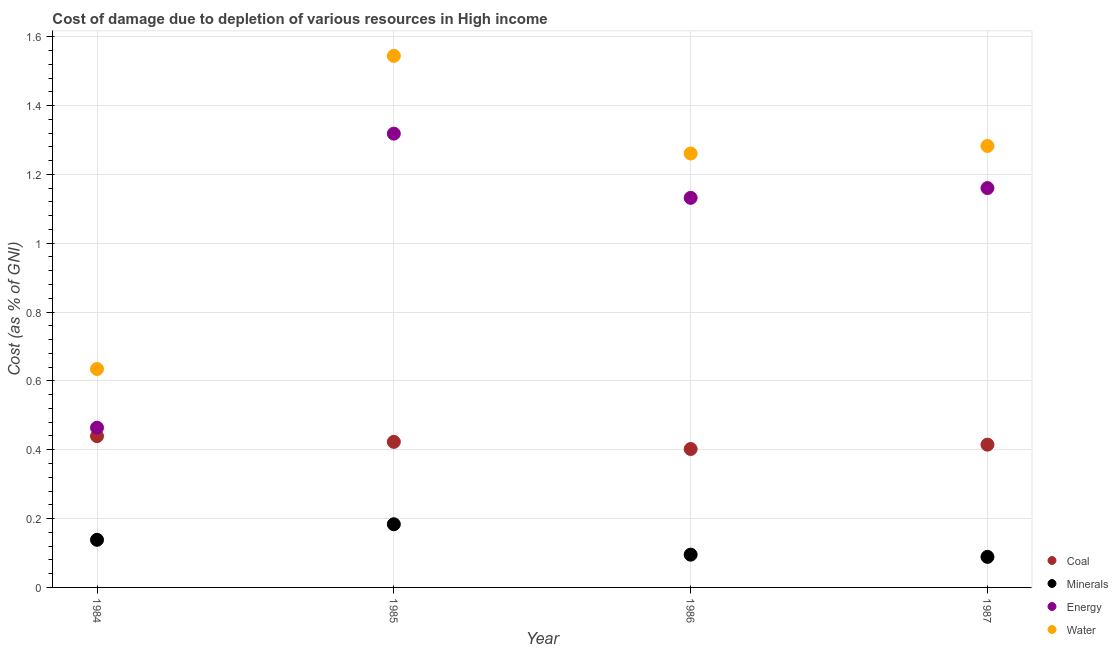How many different coloured dotlines are there?
Your response must be concise. 4. Is the number of dotlines equal to the number of legend labels?
Give a very brief answer. Yes. What is the cost of damage due to depletion of water in 1986?
Make the answer very short. 1.26. Across all years, what is the maximum cost of damage due to depletion of minerals?
Keep it short and to the point. 0.18. Across all years, what is the minimum cost of damage due to depletion of water?
Your answer should be very brief. 0.63. In which year was the cost of damage due to depletion of minerals maximum?
Provide a succinct answer. 1985. In which year was the cost of damage due to depletion of energy minimum?
Keep it short and to the point. 1984. What is the total cost of damage due to depletion of coal in the graph?
Keep it short and to the point. 1.68. What is the difference between the cost of damage due to depletion of water in 1984 and that in 1987?
Offer a terse response. -0.65. What is the difference between the cost of damage due to depletion of coal in 1987 and the cost of damage due to depletion of energy in 1984?
Offer a terse response. -0.05. What is the average cost of damage due to depletion of minerals per year?
Give a very brief answer. 0.13. In the year 1987, what is the difference between the cost of damage due to depletion of minerals and cost of damage due to depletion of coal?
Provide a short and direct response. -0.33. In how many years, is the cost of damage due to depletion of energy greater than 0.28 %?
Your response must be concise. 4. What is the ratio of the cost of damage due to depletion of minerals in 1986 to that in 1987?
Provide a succinct answer. 1.07. Is the cost of damage due to depletion of energy in 1985 less than that in 1987?
Your answer should be very brief. No. Is the difference between the cost of damage due to depletion of coal in 1984 and 1987 greater than the difference between the cost of damage due to depletion of water in 1984 and 1987?
Offer a terse response. Yes. What is the difference between the highest and the second highest cost of damage due to depletion of water?
Give a very brief answer. 0.26. What is the difference between the highest and the lowest cost of damage due to depletion of energy?
Your answer should be compact. 0.85. Is the sum of the cost of damage due to depletion of coal in 1984 and 1987 greater than the maximum cost of damage due to depletion of water across all years?
Offer a terse response. No. Is it the case that in every year, the sum of the cost of damage due to depletion of water and cost of damage due to depletion of minerals is greater than the sum of cost of damage due to depletion of coal and cost of damage due to depletion of energy?
Your answer should be compact. No. Is the cost of damage due to depletion of minerals strictly greater than the cost of damage due to depletion of water over the years?
Your answer should be very brief. No. How many dotlines are there?
Keep it short and to the point. 4. How many years are there in the graph?
Ensure brevity in your answer.  4. What is the difference between two consecutive major ticks on the Y-axis?
Give a very brief answer. 0.2. How are the legend labels stacked?
Keep it short and to the point. Vertical. What is the title of the graph?
Give a very brief answer. Cost of damage due to depletion of various resources in High income . Does "Grants and Revenue" appear as one of the legend labels in the graph?
Ensure brevity in your answer.  No. What is the label or title of the Y-axis?
Give a very brief answer. Cost (as % of GNI). What is the Cost (as % of GNI) of Coal in 1984?
Your answer should be very brief. 0.44. What is the Cost (as % of GNI) in Minerals in 1984?
Your answer should be very brief. 0.14. What is the Cost (as % of GNI) of Energy in 1984?
Offer a very short reply. 0.46. What is the Cost (as % of GNI) of Water in 1984?
Keep it short and to the point. 0.63. What is the Cost (as % of GNI) in Coal in 1985?
Your answer should be compact. 0.42. What is the Cost (as % of GNI) in Minerals in 1985?
Give a very brief answer. 0.18. What is the Cost (as % of GNI) of Energy in 1985?
Your response must be concise. 1.32. What is the Cost (as % of GNI) in Water in 1985?
Provide a short and direct response. 1.54. What is the Cost (as % of GNI) in Coal in 1986?
Keep it short and to the point. 0.4. What is the Cost (as % of GNI) of Minerals in 1986?
Offer a very short reply. 0.1. What is the Cost (as % of GNI) in Energy in 1986?
Your answer should be very brief. 1.13. What is the Cost (as % of GNI) in Water in 1986?
Ensure brevity in your answer.  1.26. What is the Cost (as % of GNI) in Coal in 1987?
Your response must be concise. 0.41. What is the Cost (as % of GNI) in Minerals in 1987?
Offer a very short reply. 0.09. What is the Cost (as % of GNI) of Energy in 1987?
Provide a short and direct response. 1.16. What is the Cost (as % of GNI) of Water in 1987?
Make the answer very short. 1.28. Across all years, what is the maximum Cost (as % of GNI) of Coal?
Ensure brevity in your answer.  0.44. Across all years, what is the maximum Cost (as % of GNI) in Minerals?
Your response must be concise. 0.18. Across all years, what is the maximum Cost (as % of GNI) of Energy?
Your response must be concise. 1.32. Across all years, what is the maximum Cost (as % of GNI) of Water?
Your response must be concise. 1.54. Across all years, what is the minimum Cost (as % of GNI) of Coal?
Your answer should be compact. 0.4. Across all years, what is the minimum Cost (as % of GNI) in Minerals?
Offer a terse response. 0.09. Across all years, what is the minimum Cost (as % of GNI) in Energy?
Keep it short and to the point. 0.46. Across all years, what is the minimum Cost (as % of GNI) in Water?
Provide a short and direct response. 0.63. What is the total Cost (as % of GNI) in Coal in the graph?
Ensure brevity in your answer.  1.68. What is the total Cost (as % of GNI) of Minerals in the graph?
Your answer should be compact. 0.51. What is the total Cost (as % of GNI) of Energy in the graph?
Ensure brevity in your answer.  4.07. What is the total Cost (as % of GNI) in Water in the graph?
Make the answer very short. 4.72. What is the difference between the Cost (as % of GNI) of Coal in 1984 and that in 1985?
Your answer should be very brief. 0.02. What is the difference between the Cost (as % of GNI) of Minerals in 1984 and that in 1985?
Your response must be concise. -0.05. What is the difference between the Cost (as % of GNI) in Energy in 1984 and that in 1985?
Offer a terse response. -0.85. What is the difference between the Cost (as % of GNI) of Water in 1984 and that in 1985?
Your answer should be very brief. -0.91. What is the difference between the Cost (as % of GNI) in Coal in 1984 and that in 1986?
Ensure brevity in your answer.  0.04. What is the difference between the Cost (as % of GNI) of Minerals in 1984 and that in 1986?
Keep it short and to the point. 0.04. What is the difference between the Cost (as % of GNI) of Energy in 1984 and that in 1986?
Provide a succinct answer. -0.67. What is the difference between the Cost (as % of GNI) of Water in 1984 and that in 1986?
Offer a very short reply. -0.63. What is the difference between the Cost (as % of GNI) of Coal in 1984 and that in 1987?
Your response must be concise. 0.02. What is the difference between the Cost (as % of GNI) of Minerals in 1984 and that in 1987?
Offer a terse response. 0.05. What is the difference between the Cost (as % of GNI) in Energy in 1984 and that in 1987?
Your answer should be compact. -0.7. What is the difference between the Cost (as % of GNI) of Water in 1984 and that in 1987?
Your answer should be compact. -0.65. What is the difference between the Cost (as % of GNI) in Coal in 1985 and that in 1986?
Offer a very short reply. 0.02. What is the difference between the Cost (as % of GNI) of Minerals in 1985 and that in 1986?
Offer a terse response. 0.09. What is the difference between the Cost (as % of GNI) in Energy in 1985 and that in 1986?
Provide a short and direct response. 0.19. What is the difference between the Cost (as % of GNI) in Water in 1985 and that in 1986?
Your response must be concise. 0.28. What is the difference between the Cost (as % of GNI) in Coal in 1985 and that in 1987?
Provide a succinct answer. 0.01. What is the difference between the Cost (as % of GNI) in Minerals in 1985 and that in 1987?
Keep it short and to the point. 0.09. What is the difference between the Cost (as % of GNI) in Energy in 1985 and that in 1987?
Give a very brief answer. 0.16. What is the difference between the Cost (as % of GNI) of Water in 1985 and that in 1987?
Ensure brevity in your answer.  0.26. What is the difference between the Cost (as % of GNI) in Coal in 1986 and that in 1987?
Provide a succinct answer. -0.01. What is the difference between the Cost (as % of GNI) in Minerals in 1986 and that in 1987?
Your response must be concise. 0.01. What is the difference between the Cost (as % of GNI) of Energy in 1986 and that in 1987?
Offer a very short reply. -0.03. What is the difference between the Cost (as % of GNI) in Water in 1986 and that in 1987?
Offer a terse response. -0.02. What is the difference between the Cost (as % of GNI) of Coal in 1984 and the Cost (as % of GNI) of Minerals in 1985?
Ensure brevity in your answer.  0.26. What is the difference between the Cost (as % of GNI) in Coal in 1984 and the Cost (as % of GNI) in Energy in 1985?
Keep it short and to the point. -0.88. What is the difference between the Cost (as % of GNI) in Coal in 1984 and the Cost (as % of GNI) in Water in 1985?
Offer a very short reply. -1.1. What is the difference between the Cost (as % of GNI) of Minerals in 1984 and the Cost (as % of GNI) of Energy in 1985?
Make the answer very short. -1.18. What is the difference between the Cost (as % of GNI) of Minerals in 1984 and the Cost (as % of GNI) of Water in 1985?
Offer a very short reply. -1.41. What is the difference between the Cost (as % of GNI) in Energy in 1984 and the Cost (as % of GNI) in Water in 1985?
Provide a short and direct response. -1.08. What is the difference between the Cost (as % of GNI) in Coal in 1984 and the Cost (as % of GNI) in Minerals in 1986?
Offer a very short reply. 0.34. What is the difference between the Cost (as % of GNI) in Coal in 1984 and the Cost (as % of GNI) in Energy in 1986?
Offer a very short reply. -0.69. What is the difference between the Cost (as % of GNI) of Coal in 1984 and the Cost (as % of GNI) of Water in 1986?
Ensure brevity in your answer.  -0.82. What is the difference between the Cost (as % of GNI) of Minerals in 1984 and the Cost (as % of GNI) of Energy in 1986?
Make the answer very short. -0.99. What is the difference between the Cost (as % of GNI) of Minerals in 1984 and the Cost (as % of GNI) of Water in 1986?
Keep it short and to the point. -1.12. What is the difference between the Cost (as % of GNI) of Energy in 1984 and the Cost (as % of GNI) of Water in 1986?
Your answer should be very brief. -0.8. What is the difference between the Cost (as % of GNI) of Coal in 1984 and the Cost (as % of GNI) of Minerals in 1987?
Your answer should be compact. 0.35. What is the difference between the Cost (as % of GNI) of Coal in 1984 and the Cost (as % of GNI) of Energy in 1987?
Provide a succinct answer. -0.72. What is the difference between the Cost (as % of GNI) of Coal in 1984 and the Cost (as % of GNI) of Water in 1987?
Your response must be concise. -0.84. What is the difference between the Cost (as % of GNI) of Minerals in 1984 and the Cost (as % of GNI) of Energy in 1987?
Your answer should be very brief. -1.02. What is the difference between the Cost (as % of GNI) of Minerals in 1984 and the Cost (as % of GNI) of Water in 1987?
Ensure brevity in your answer.  -1.14. What is the difference between the Cost (as % of GNI) of Energy in 1984 and the Cost (as % of GNI) of Water in 1987?
Make the answer very short. -0.82. What is the difference between the Cost (as % of GNI) of Coal in 1985 and the Cost (as % of GNI) of Minerals in 1986?
Provide a short and direct response. 0.33. What is the difference between the Cost (as % of GNI) of Coal in 1985 and the Cost (as % of GNI) of Energy in 1986?
Provide a short and direct response. -0.71. What is the difference between the Cost (as % of GNI) in Coal in 1985 and the Cost (as % of GNI) in Water in 1986?
Provide a succinct answer. -0.84. What is the difference between the Cost (as % of GNI) of Minerals in 1985 and the Cost (as % of GNI) of Energy in 1986?
Ensure brevity in your answer.  -0.95. What is the difference between the Cost (as % of GNI) of Minerals in 1985 and the Cost (as % of GNI) of Water in 1986?
Your answer should be very brief. -1.08. What is the difference between the Cost (as % of GNI) of Energy in 1985 and the Cost (as % of GNI) of Water in 1986?
Offer a terse response. 0.06. What is the difference between the Cost (as % of GNI) of Coal in 1985 and the Cost (as % of GNI) of Minerals in 1987?
Offer a terse response. 0.33. What is the difference between the Cost (as % of GNI) of Coal in 1985 and the Cost (as % of GNI) of Energy in 1987?
Your response must be concise. -0.74. What is the difference between the Cost (as % of GNI) in Coal in 1985 and the Cost (as % of GNI) in Water in 1987?
Your response must be concise. -0.86. What is the difference between the Cost (as % of GNI) in Minerals in 1985 and the Cost (as % of GNI) in Energy in 1987?
Give a very brief answer. -0.98. What is the difference between the Cost (as % of GNI) in Minerals in 1985 and the Cost (as % of GNI) in Water in 1987?
Keep it short and to the point. -1.1. What is the difference between the Cost (as % of GNI) of Energy in 1985 and the Cost (as % of GNI) of Water in 1987?
Make the answer very short. 0.04. What is the difference between the Cost (as % of GNI) in Coal in 1986 and the Cost (as % of GNI) in Minerals in 1987?
Ensure brevity in your answer.  0.31. What is the difference between the Cost (as % of GNI) in Coal in 1986 and the Cost (as % of GNI) in Energy in 1987?
Provide a short and direct response. -0.76. What is the difference between the Cost (as % of GNI) in Coal in 1986 and the Cost (as % of GNI) in Water in 1987?
Give a very brief answer. -0.88. What is the difference between the Cost (as % of GNI) of Minerals in 1986 and the Cost (as % of GNI) of Energy in 1987?
Make the answer very short. -1.07. What is the difference between the Cost (as % of GNI) in Minerals in 1986 and the Cost (as % of GNI) in Water in 1987?
Your answer should be compact. -1.19. What is the difference between the Cost (as % of GNI) in Energy in 1986 and the Cost (as % of GNI) in Water in 1987?
Give a very brief answer. -0.15. What is the average Cost (as % of GNI) of Coal per year?
Offer a very short reply. 0.42. What is the average Cost (as % of GNI) of Minerals per year?
Offer a very short reply. 0.13. What is the average Cost (as % of GNI) in Energy per year?
Your answer should be very brief. 1.02. What is the average Cost (as % of GNI) of Water per year?
Your response must be concise. 1.18. In the year 1984, what is the difference between the Cost (as % of GNI) of Coal and Cost (as % of GNI) of Minerals?
Offer a very short reply. 0.3. In the year 1984, what is the difference between the Cost (as % of GNI) in Coal and Cost (as % of GNI) in Energy?
Offer a terse response. -0.02. In the year 1984, what is the difference between the Cost (as % of GNI) of Coal and Cost (as % of GNI) of Water?
Offer a very short reply. -0.2. In the year 1984, what is the difference between the Cost (as % of GNI) of Minerals and Cost (as % of GNI) of Energy?
Your response must be concise. -0.33. In the year 1984, what is the difference between the Cost (as % of GNI) of Minerals and Cost (as % of GNI) of Water?
Ensure brevity in your answer.  -0.5. In the year 1984, what is the difference between the Cost (as % of GNI) in Energy and Cost (as % of GNI) in Water?
Your answer should be very brief. -0.17. In the year 1985, what is the difference between the Cost (as % of GNI) in Coal and Cost (as % of GNI) in Minerals?
Give a very brief answer. 0.24. In the year 1985, what is the difference between the Cost (as % of GNI) of Coal and Cost (as % of GNI) of Energy?
Make the answer very short. -0.9. In the year 1985, what is the difference between the Cost (as % of GNI) in Coal and Cost (as % of GNI) in Water?
Offer a terse response. -1.12. In the year 1985, what is the difference between the Cost (as % of GNI) in Minerals and Cost (as % of GNI) in Energy?
Keep it short and to the point. -1.13. In the year 1985, what is the difference between the Cost (as % of GNI) in Minerals and Cost (as % of GNI) in Water?
Your response must be concise. -1.36. In the year 1985, what is the difference between the Cost (as % of GNI) in Energy and Cost (as % of GNI) in Water?
Keep it short and to the point. -0.23. In the year 1986, what is the difference between the Cost (as % of GNI) in Coal and Cost (as % of GNI) in Minerals?
Make the answer very short. 0.31. In the year 1986, what is the difference between the Cost (as % of GNI) in Coal and Cost (as % of GNI) in Energy?
Provide a succinct answer. -0.73. In the year 1986, what is the difference between the Cost (as % of GNI) in Coal and Cost (as % of GNI) in Water?
Offer a terse response. -0.86. In the year 1986, what is the difference between the Cost (as % of GNI) of Minerals and Cost (as % of GNI) of Energy?
Give a very brief answer. -1.04. In the year 1986, what is the difference between the Cost (as % of GNI) of Minerals and Cost (as % of GNI) of Water?
Your answer should be compact. -1.17. In the year 1986, what is the difference between the Cost (as % of GNI) in Energy and Cost (as % of GNI) in Water?
Your response must be concise. -0.13. In the year 1987, what is the difference between the Cost (as % of GNI) in Coal and Cost (as % of GNI) in Minerals?
Provide a succinct answer. 0.33. In the year 1987, what is the difference between the Cost (as % of GNI) in Coal and Cost (as % of GNI) in Energy?
Your answer should be very brief. -0.75. In the year 1987, what is the difference between the Cost (as % of GNI) in Coal and Cost (as % of GNI) in Water?
Your response must be concise. -0.87. In the year 1987, what is the difference between the Cost (as % of GNI) in Minerals and Cost (as % of GNI) in Energy?
Provide a succinct answer. -1.07. In the year 1987, what is the difference between the Cost (as % of GNI) of Minerals and Cost (as % of GNI) of Water?
Give a very brief answer. -1.19. In the year 1987, what is the difference between the Cost (as % of GNI) in Energy and Cost (as % of GNI) in Water?
Provide a short and direct response. -0.12. What is the ratio of the Cost (as % of GNI) of Coal in 1984 to that in 1985?
Give a very brief answer. 1.04. What is the ratio of the Cost (as % of GNI) in Minerals in 1984 to that in 1985?
Provide a short and direct response. 0.75. What is the ratio of the Cost (as % of GNI) of Energy in 1984 to that in 1985?
Keep it short and to the point. 0.35. What is the ratio of the Cost (as % of GNI) of Water in 1984 to that in 1985?
Your answer should be compact. 0.41. What is the ratio of the Cost (as % of GNI) of Coal in 1984 to that in 1986?
Keep it short and to the point. 1.09. What is the ratio of the Cost (as % of GNI) of Minerals in 1984 to that in 1986?
Your answer should be very brief. 1.45. What is the ratio of the Cost (as % of GNI) in Energy in 1984 to that in 1986?
Give a very brief answer. 0.41. What is the ratio of the Cost (as % of GNI) of Water in 1984 to that in 1986?
Offer a terse response. 0.5. What is the ratio of the Cost (as % of GNI) of Coal in 1984 to that in 1987?
Keep it short and to the point. 1.06. What is the ratio of the Cost (as % of GNI) in Minerals in 1984 to that in 1987?
Your answer should be very brief. 1.56. What is the ratio of the Cost (as % of GNI) of Water in 1984 to that in 1987?
Provide a succinct answer. 0.49. What is the ratio of the Cost (as % of GNI) in Coal in 1985 to that in 1986?
Offer a very short reply. 1.05. What is the ratio of the Cost (as % of GNI) of Minerals in 1985 to that in 1986?
Your answer should be compact. 1.93. What is the ratio of the Cost (as % of GNI) of Energy in 1985 to that in 1986?
Your response must be concise. 1.16. What is the ratio of the Cost (as % of GNI) in Water in 1985 to that in 1986?
Give a very brief answer. 1.23. What is the ratio of the Cost (as % of GNI) in Coal in 1985 to that in 1987?
Your response must be concise. 1.02. What is the ratio of the Cost (as % of GNI) of Minerals in 1985 to that in 1987?
Provide a succinct answer. 2.07. What is the ratio of the Cost (as % of GNI) of Energy in 1985 to that in 1987?
Your answer should be compact. 1.14. What is the ratio of the Cost (as % of GNI) of Water in 1985 to that in 1987?
Give a very brief answer. 1.2. What is the ratio of the Cost (as % of GNI) in Coal in 1986 to that in 1987?
Provide a succinct answer. 0.97. What is the ratio of the Cost (as % of GNI) of Minerals in 1986 to that in 1987?
Keep it short and to the point. 1.07. What is the ratio of the Cost (as % of GNI) of Energy in 1986 to that in 1987?
Offer a very short reply. 0.98. What is the ratio of the Cost (as % of GNI) in Water in 1986 to that in 1987?
Ensure brevity in your answer.  0.98. What is the difference between the highest and the second highest Cost (as % of GNI) of Coal?
Offer a terse response. 0.02. What is the difference between the highest and the second highest Cost (as % of GNI) of Minerals?
Your answer should be very brief. 0.05. What is the difference between the highest and the second highest Cost (as % of GNI) of Energy?
Give a very brief answer. 0.16. What is the difference between the highest and the second highest Cost (as % of GNI) in Water?
Offer a terse response. 0.26. What is the difference between the highest and the lowest Cost (as % of GNI) in Coal?
Make the answer very short. 0.04. What is the difference between the highest and the lowest Cost (as % of GNI) in Minerals?
Your response must be concise. 0.09. What is the difference between the highest and the lowest Cost (as % of GNI) of Energy?
Make the answer very short. 0.85. What is the difference between the highest and the lowest Cost (as % of GNI) of Water?
Offer a very short reply. 0.91. 